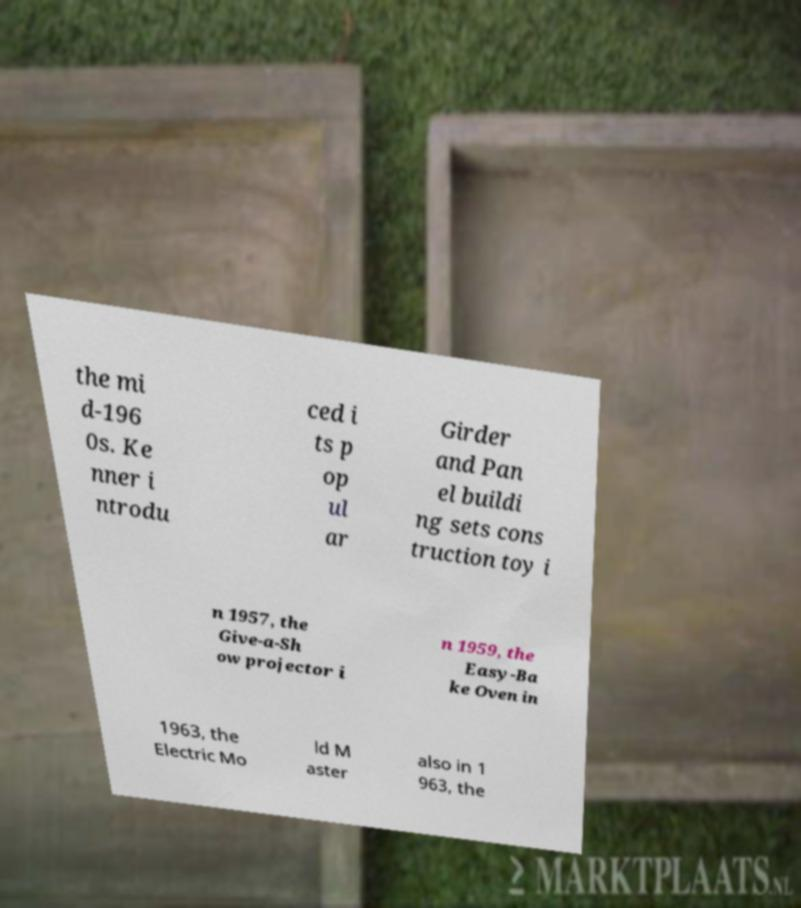Please read and relay the text visible in this image. What does it say? the mi d-196 0s. Ke nner i ntrodu ced i ts p op ul ar Girder and Pan el buildi ng sets cons truction toy i n 1957, the Give-a-Sh ow projector i n 1959, the Easy-Ba ke Oven in 1963, the Electric Mo ld M aster also in 1 963, the 